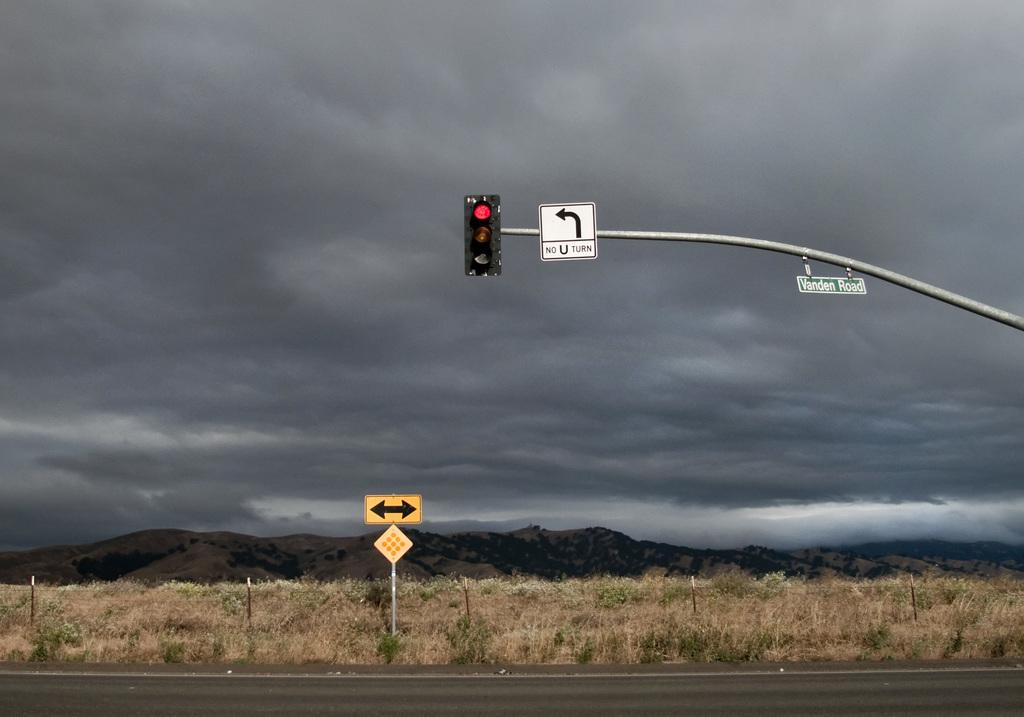<image>
Share a concise interpretation of the image provided. a sign with a one way arrow next to it on Vanden road 